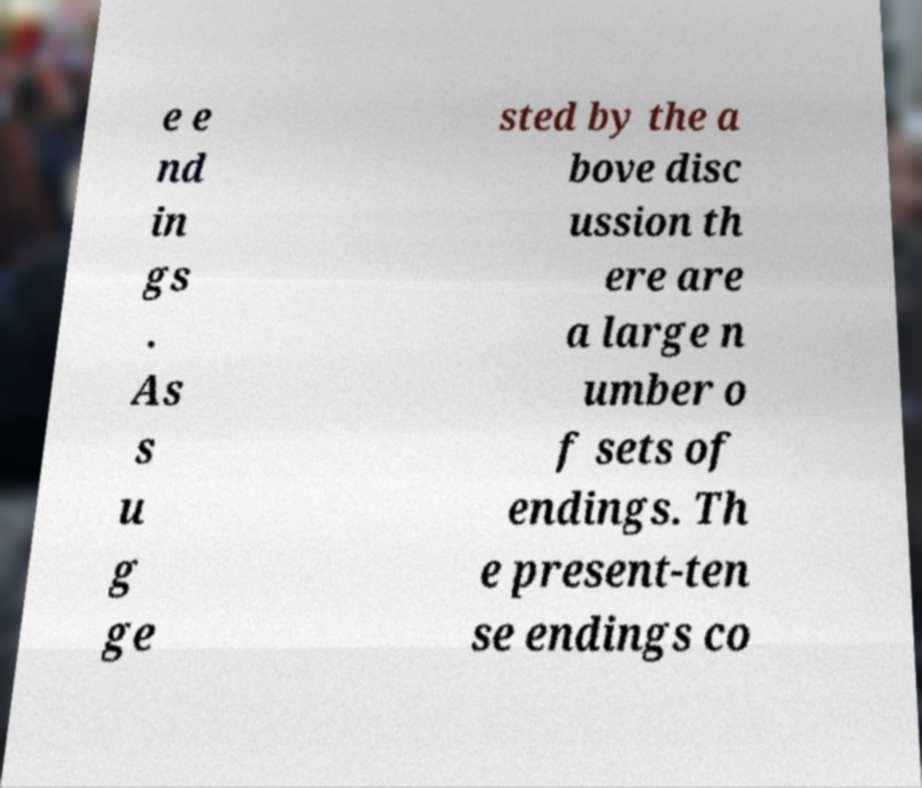Can you read and provide the text displayed in the image?This photo seems to have some interesting text. Can you extract and type it out for me? e e nd in gs . As s u g ge sted by the a bove disc ussion th ere are a large n umber o f sets of endings. Th e present-ten se endings co 